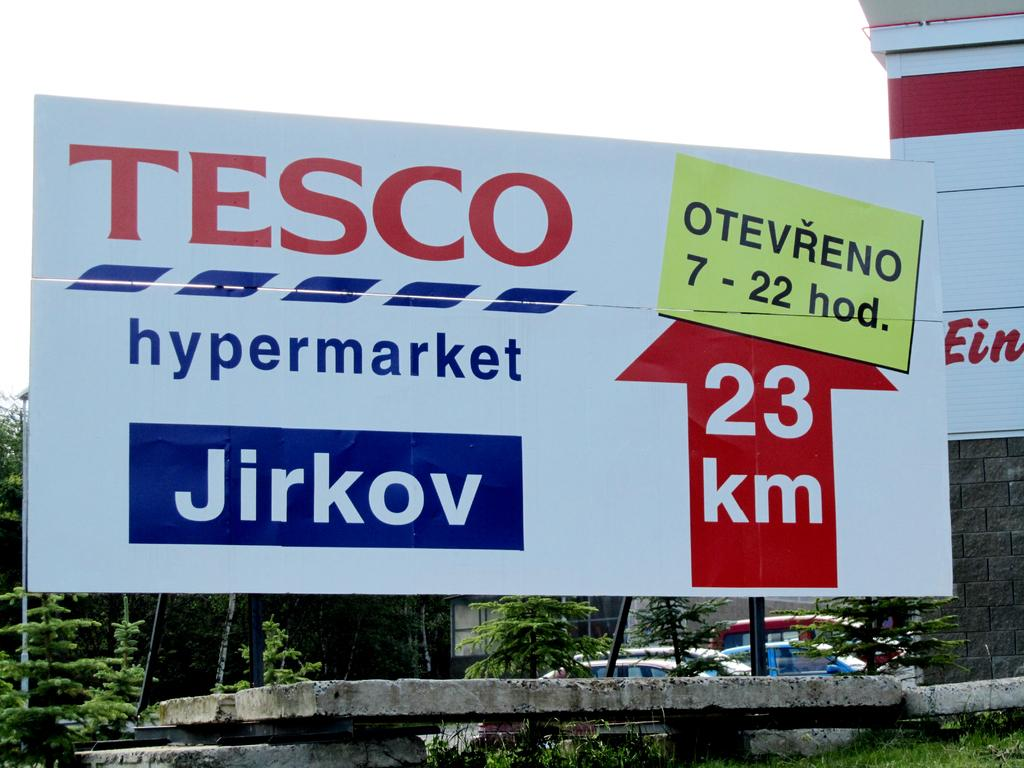<image>
Write a terse but informative summary of the picture. A picture of a sign board from TESCO that reads hypermarket Jirkov. 